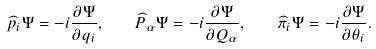<formula> <loc_0><loc_0><loc_500><loc_500>\widehat { p } _ { i } \Psi = - i \frac { \partial \Psi } { \partial q _ { i } } , \quad \widehat { P } _ { \alpha } \Psi = - i \frac { \partial \Psi } { \partial Q _ { \alpha } } , \quad \widehat { \pi } _ { i } \Psi = - i \frac { \partial \Psi } { \partial \theta _ { i } } .</formula> 